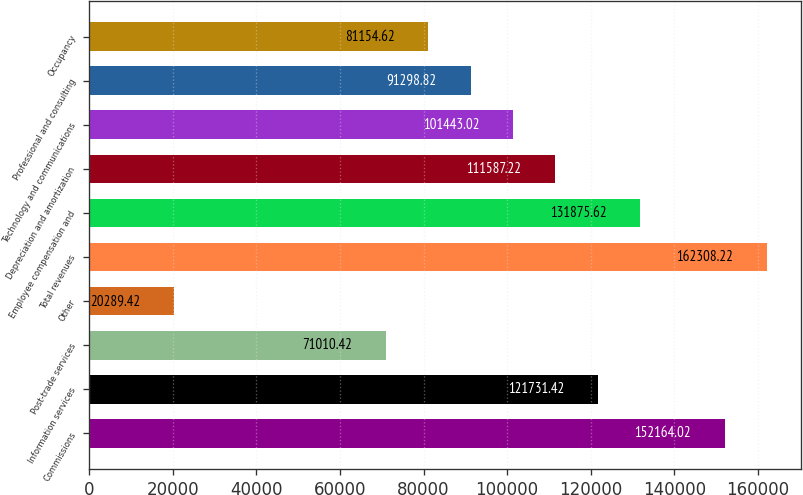<chart> <loc_0><loc_0><loc_500><loc_500><bar_chart><fcel>Commissions<fcel>Information services<fcel>Post-trade services<fcel>Other<fcel>Total revenues<fcel>Employee compensation and<fcel>Depreciation and amortization<fcel>Technology and communications<fcel>Professional and consulting<fcel>Occupancy<nl><fcel>152164<fcel>121731<fcel>71010.4<fcel>20289.4<fcel>162308<fcel>131876<fcel>111587<fcel>101443<fcel>91298.8<fcel>81154.6<nl></chart> 